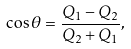Convert formula to latex. <formula><loc_0><loc_0><loc_500><loc_500>\cos \theta = \frac { Q _ { 1 } - Q _ { 2 } } { Q _ { 2 } + Q _ { 1 } } ,</formula> 